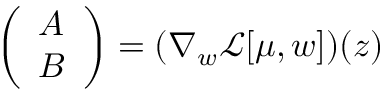Convert formula to latex. <formula><loc_0><loc_0><loc_500><loc_500>\left ( \begin{array} { l } { A } \\ { B } \end{array} \right ) = ( \nabla _ { w } \mathcal { L } [ \mu , w ] ) ( z )</formula> 